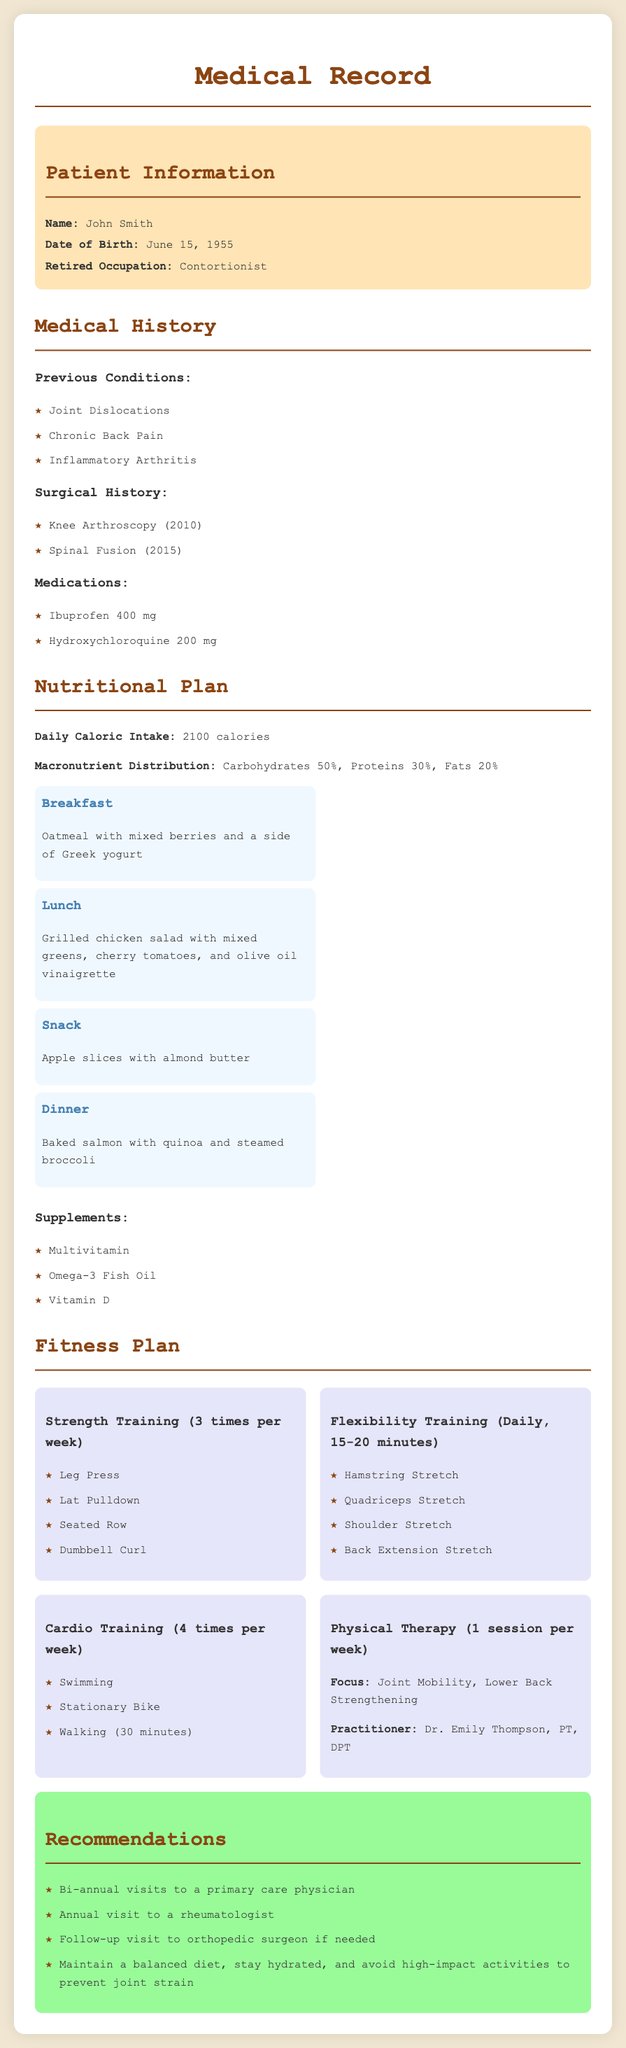What is the patient's name? The document provides the patient's name in the patient information section, which is John Smith.
Answer: John Smith What is the date of birth? The date of birth is specified under patient information, which is June 15, 1955.
Answer: June 15, 1955 What is the daily caloric intake recommended? The specific caloric intake can be found in the nutritional plan section, listed as 2100 calories.
Answer: 2100 calories How often should strength training be performed? The fitness plan indicates that strength training should be performed 3 times per week.
Answer: 3 times per week What medication is prescribed for chronic pain? The medications section lists Ibuprofen 400 mg as a treatment for pain.
Answer: Ibuprofen 400 mg What percentage of the diet should come from proteins? The macronutrient distribution mentions that 30% of the diet should come from proteins.
Answer: 30% Who is the practitioner for physical therapy? The document states that the physical therapy practitioner is Dr. Emily Thompson, PT, DPT.
Answer: Dr. Emily Thompson, PT, DPT What type of training is emphasized daily? The fitness plan highlights flexibility training as a daily activity for 15-20 minutes.
Answer: Flexibility training What is one recommendation made in the document? The recommendations section includes a suggestion to maintain a balanced diet.
Answer: Maintain a balanced diet 